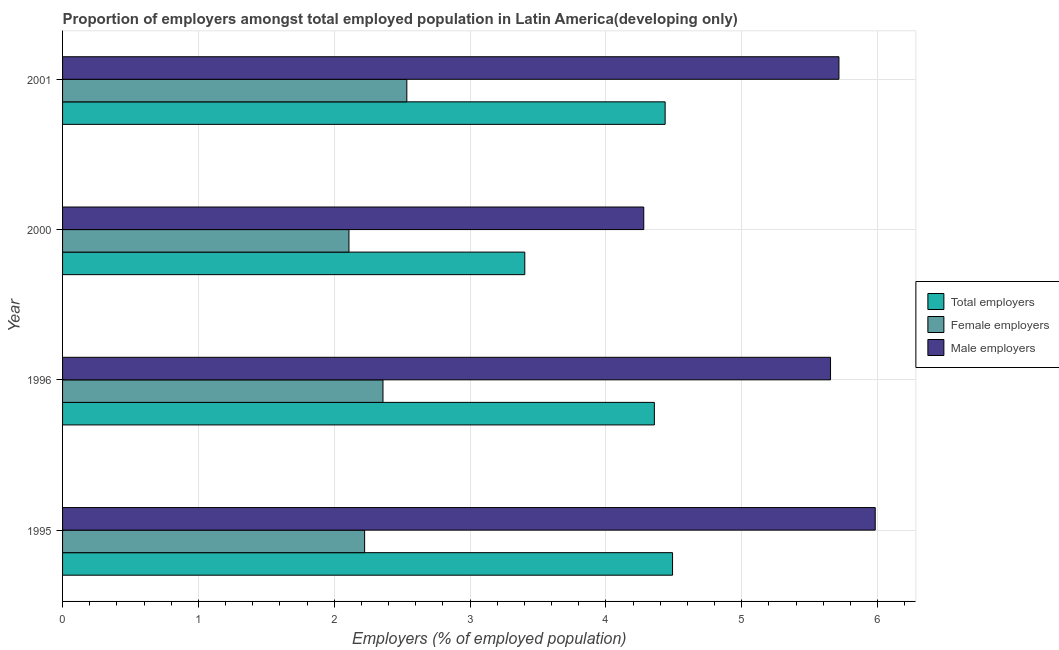Are the number of bars per tick equal to the number of legend labels?
Provide a short and direct response. Yes. Are the number of bars on each tick of the Y-axis equal?
Your answer should be compact. Yes. What is the label of the 2nd group of bars from the top?
Give a very brief answer. 2000. What is the percentage of female employers in 2001?
Keep it short and to the point. 2.53. Across all years, what is the maximum percentage of male employers?
Make the answer very short. 5.98. Across all years, what is the minimum percentage of total employers?
Offer a very short reply. 3.4. In which year was the percentage of total employers maximum?
Provide a short and direct response. 1995. In which year was the percentage of male employers minimum?
Your answer should be compact. 2000. What is the total percentage of total employers in the graph?
Your answer should be compact. 16.69. What is the difference between the percentage of male employers in 1995 and that in 2000?
Your answer should be compact. 1.7. What is the difference between the percentage of female employers in 2000 and the percentage of total employers in 1996?
Provide a short and direct response. -2.25. What is the average percentage of female employers per year?
Give a very brief answer. 2.31. In the year 2001, what is the difference between the percentage of total employers and percentage of male employers?
Provide a succinct answer. -1.28. What is the ratio of the percentage of total employers in 2000 to that in 2001?
Provide a short and direct response. 0.77. Is the percentage of male employers in 1995 less than that in 2000?
Offer a very short reply. No. What is the difference between the highest and the second highest percentage of female employers?
Offer a terse response. 0.18. What is the difference between the highest and the lowest percentage of total employers?
Your answer should be compact. 1.09. In how many years, is the percentage of total employers greater than the average percentage of total employers taken over all years?
Offer a very short reply. 3. Is the sum of the percentage of total employers in 1996 and 2001 greater than the maximum percentage of male employers across all years?
Provide a succinct answer. Yes. What does the 3rd bar from the top in 2000 represents?
Your response must be concise. Total employers. What does the 3rd bar from the bottom in 2001 represents?
Offer a very short reply. Male employers. How many years are there in the graph?
Provide a succinct answer. 4. Are the values on the major ticks of X-axis written in scientific E-notation?
Provide a succinct answer. No. Where does the legend appear in the graph?
Make the answer very short. Center right. How many legend labels are there?
Offer a terse response. 3. What is the title of the graph?
Make the answer very short. Proportion of employers amongst total employed population in Latin America(developing only). Does "Neonatal" appear as one of the legend labels in the graph?
Make the answer very short. No. What is the label or title of the X-axis?
Make the answer very short. Employers (% of employed population). What is the label or title of the Y-axis?
Keep it short and to the point. Year. What is the Employers (% of employed population) in Total employers in 1995?
Make the answer very short. 4.49. What is the Employers (% of employed population) of Female employers in 1995?
Keep it short and to the point. 2.22. What is the Employers (% of employed population) of Male employers in 1995?
Your answer should be very brief. 5.98. What is the Employers (% of employed population) in Total employers in 1996?
Ensure brevity in your answer.  4.36. What is the Employers (% of employed population) in Female employers in 1996?
Provide a succinct answer. 2.36. What is the Employers (% of employed population) of Male employers in 1996?
Give a very brief answer. 5.65. What is the Employers (% of employed population) in Total employers in 2000?
Ensure brevity in your answer.  3.4. What is the Employers (% of employed population) of Female employers in 2000?
Provide a short and direct response. 2.11. What is the Employers (% of employed population) in Male employers in 2000?
Keep it short and to the point. 4.28. What is the Employers (% of employed population) in Total employers in 2001?
Provide a short and direct response. 4.44. What is the Employers (% of employed population) in Female employers in 2001?
Keep it short and to the point. 2.53. What is the Employers (% of employed population) of Male employers in 2001?
Keep it short and to the point. 5.72. Across all years, what is the maximum Employers (% of employed population) in Total employers?
Make the answer very short. 4.49. Across all years, what is the maximum Employers (% of employed population) of Female employers?
Provide a succinct answer. 2.53. Across all years, what is the maximum Employers (% of employed population) in Male employers?
Your answer should be compact. 5.98. Across all years, what is the minimum Employers (% of employed population) of Total employers?
Provide a succinct answer. 3.4. Across all years, what is the minimum Employers (% of employed population) of Female employers?
Provide a short and direct response. 2.11. Across all years, what is the minimum Employers (% of employed population) of Male employers?
Provide a succinct answer. 4.28. What is the total Employers (% of employed population) of Total employers in the graph?
Your answer should be compact. 16.69. What is the total Employers (% of employed population) of Female employers in the graph?
Offer a very short reply. 9.22. What is the total Employers (% of employed population) of Male employers in the graph?
Your answer should be compact. 21.63. What is the difference between the Employers (% of employed population) of Total employers in 1995 and that in 1996?
Provide a succinct answer. 0.13. What is the difference between the Employers (% of employed population) of Female employers in 1995 and that in 1996?
Your response must be concise. -0.14. What is the difference between the Employers (% of employed population) of Male employers in 1995 and that in 1996?
Your response must be concise. 0.33. What is the difference between the Employers (% of employed population) in Total employers in 1995 and that in 2000?
Keep it short and to the point. 1.09. What is the difference between the Employers (% of employed population) in Female employers in 1995 and that in 2000?
Provide a short and direct response. 0.12. What is the difference between the Employers (% of employed population) in Male employers in 1995 and that in 2000?
Provide a short and direct response. 1.7. What is the difference between the Employers (% of employed population) of Total employers in 1995 and that in 2001?
Your response must be concise. 0.05. What is the difference between the Employers (% of employed population) in Female employers in 1995 and that in 2001?
Provide a succinct answer. -0.31. What is the difference between the Employers (% of employed population) of Male employers in 1995 and that in 2001?
Your answer should be compact. 0.27. What is the difference between the Employers (% of employed population) in Total employers in 1996 and that in 2000?
Give a very brief answer. 0.95. What is the difference between the Employers (% of employed population) of Female employers in 1996 and that in 2000?
Your answer should be very brief. 0.25. What is the difference between the Employers (% of employed population) in Male employers in 1996 and that in 2000?
Your response must be concise. 1.37. What is the difference between the Employers (% of employed population) of Total employers in 1996 and that in 2001?
Offer a terse response. -0.08. What is the difference between the Employers (% of employed population) of Female employers in 1996 and that in 2001?
Offer a terse response. -0.18. What is the difference between the Employers (% of employed population) in Male employers in 1996 and that in 2001?
Offer a very short reply. -0.06. What is the difference between the Employers (% of employed population) in Total employers in 2000 and that in 2001?
Keep it short and to the point. -1.03. What is the difference between the Employers (% of employed population) of Female employers in 2000 and that in 2001?
Offer a terse response. -0.43. What is the difference between the Employers (% of employed population) in Male employers in 2000 and that in 2001?
Offer a terse response. -1.44. What is the difference between the Employers (% of employed population) of Total employers in 1995 and the Employers (% of employed population) of Female employers in 1996?
Make the answer very short. 2.13. What is the difference between the Employers (% of employed population) in Total employers in 1995 and the Employers (% of employed population) in Male employers in 1996?
Provide a succinct answer. -1.16. What is the difference between the Employers (% of employed population) of Female employers in 1995 and the Employers (% of employed population) of Male employers in 1996?
Provide a short and direct response. -3.43. What is the difference between the Employers (% of employed population) in Total employers in 1995 and the Employers (% of employed population) in Female employers in 2000?
Your response must be concise. 2.38. What is the difference between the Employers (% of employed population) of Total employers in 1995 and the Employers (% of employed population) of Male employers in 2000?
Offer a terse response. 0.21. What is the difference between the Employers (% of employed population) of Female employers in 1995 and the Employers (% of employed population) of Male employers in 2000?
Make the answer very short. -2.05. What is the difference between the Employers (% of employed population) in Total employers in 1995 and the Employers (% of employed population) in Female employers in 2001?
Keep it short and to the point. 1.96. What is the difference between the Employers (% of employed population) of Total employers in 1995 and the Employers (% of employed population) of Male employers in 2001?
Give a very brief answer. -1.22. What is the difference between the Employers (% of employed population) of Female employers in 1995 and the Employers (% of employed population) of Male employers in 2001?
Provide a succinct answer. -3.49. What is the difference between the Employers (% of employed population) in Total employers in 1996 and the Employers (% of employed population) in Female employers in 2000?
Ensure brevity in your answer.  2.25. What is the difference between the Employers (% of employed population) of Total employers in 1996 and the Employers (% of employed population) of Male employers in 2000?
Ensure brevity in your answer.  0.08. What is the difference between the Employers (% of employed population) in Female employers in 1996 and the Employers (% of employed population) in Male employers in 2000?
Ensure brevity in your answer.  -1.92. What is the difference between the Employers (% of employed population) of Total employers in 1996 and the Employers (% of employed population) of Female employers in 2001?
Provide a short and direct response. 1.82. What is the difference between the Employers (% of employed population) of Total employers in 1996 and the Employers (% of employed population) of Male employers in 2001?
Your answer should be very brief. -1.36. What is the difference between the Employers (% of employed population) in Female employers in 1996 and the Employers (% of employed population) in Male employers in 2001?
Ensure brevity in your answer.  -3.36. What is the difference between the Employers (% of employed population) of Total employers in 2000 and the Employers (% of employed population) of Female employers in 2001?
Your answer should be compact. 0.87. What is the difference between the Employers (% of employed population) in Total employers in 2000 and the Employers (% of employed population) in Male employers in 2001?
Your answer should be very brief. -2.31. What is the difference between the Employers (% of employed population) in Female employers in 2000 and the Employers (% of employed population) in Male employers in 2001?
Provide a succinct answer. -3.61. What is the average Employers (% of employed population) in Total employers per year?
Keep it short and to the point. 4.17. What is the average Employers (% of employed population) of Female employers per year?
Give a very brief answer. 2.31. What is the average Employers (% of employed population) in Male employers per year?
Give a very brief answer. 5.41. In the year 1995, what is the difference between the Employers (% of employed population) of Total employers and Employers (% of employed population) of Female employers?
Your response must be concise. 2.27. In the year 1995, what is the difference between the Employers (% of employed population) in Total employers and Employers (% of employed population) in Male employers?
Provide a succinct answer. -1.49. In the year 1995, what is the difference between the Employers (% of employed population) of Female employers and Employers (% of employed population) of Male employers?
Offer a very short reply. -3.76. In the year 1996, what is the difference between the Employers (% of employed population) of Total employers and Employers (% of employed population) of Female employers?
Provide a succinct answer. 2. In the year 1996, what is the difference between the Employers (% of employed population) of Total employers and Employers (% of employed population) of Male employers?
Ensure brevity in your answer.  -1.3. In the year 1996, what is the difference between the Employers (% of employed population) of Female employers and Employers (% of employed population) of Male employers?
Your response must be concise. -3.29. In the year 2000, what is the difference between the Employers (% of employed population) of Total employers and Employers (% of employed population) of Female employers?
Your answer should be very brief. 1.29. In the year 2000, what is the difference between the Employers (% of employed population) of Total employers and Employers (% of employed population) of Male employers?
Provide a short and direct response. -0.88. In the year 2000, what is the difference between the Employers (% of employed population) in Female employers and Employers (% of employed population) in Male employers?
Offer a very short reply. -2.17. In the year 2001, what is the difference between the Employers (% of employed population) of Total employers and Employers (% of employed population) of Female employers?
Provide a succinct answer. 1.9. In the year 2001, what is the difference between the Employers (% of employed population) of Total employers and Employers (% of employed population) of Male employers?
Keep it short and to the point. -1.28. In the year 2001, what is the difference between the Employers (% of employed population) of Female employers and Employers (% of employed population) of Male employers?
Offer a very short reply. -3.18. What is the ratio of the Employers (% of employed population) in Total employers in 1995 to that in 1996?
Make the answer very short. 1.03. What is the ratio of the Employers (% of employed population) of Female employers in 1995 to that in 1996?
Offer a terse response. 0.94. What is the ratio of the Employers (% of employed population) of Male employers in 1995 to that in 1996?
Your answer should be compact. 1.06. What is the ratio of the Employers (% of employed population) of Total employers in 1995 to that in 2000?
Your answer should be compact. 1.32. What is the ratio of the Employers (% of employed population) of Female employers in 1995 to that in 2000?
Offer a terse response. 1.05. What is the ratio of the Employers (% of employed population) of Male employers in 1995 to that in 2000?
Provide a short and direct response. 1.4. What is the ratio of the Employers (% of employed population) of Total employers in 1995 to that in 2001?
Provide a short and direct response. 1.01. What is the ratio of the Employers (% of employed population) of Female employers in 1995 to that in 2001?
Offer a very short reply. 0.88. What is the ratio of the Employers (% of employed population) of Male employers in 1995 to that in 2001?
Your answer should be compact. 1.05. What is the ratio of the Employers (% of employed population) of Total employers in 1996 to that in 2000?
Your answer should be very brief. 1.28. What is the ratio of the Employers (% of employed population) of Female employers in 1996 to that in 2000?
Give a very brief answer. 1.12. What is the ratio of the Employers (% of employed population) in Male employers in 1996 to that in 2000?
Offer a very short reply. 1.32. What is the ratio of the Employers (% of employed population) of Total employers in 1996 to that in 2001?
Make the answer very short. 0.98. What is the ratio of the Employers (% of employed population) in Female employers in 1996 to that in 2001?
Provide a short and direct response. 0.93. What is the ratio of the Employers (% of employed population) of Male employers in 1996 to that in 2001?
Provide a succinct answer. 0.99. What is the ratio of the Employers (% of employed population) of Total employers in 2000 to that in 2001?
Keep it short and to the point. 0.77. What is the ratio of the Employers (% of employed population) in Female employers in 2000 to that in 2001?
Your response must be concise. 0.83. What is the ratio of the Employers (% of employed population) of Male employers in 2000 to that in 2001?
Keep it short and to the point. 0.75. What is the difference between the highest and the second highest Employers (% of employed population) in Total employers?
Your answer should be very brief. 0.05. What is the difference between the highest and the second highest Employers (% of employed population) of Female employers?
Make the answer very short. 0.18. What is the difference between the highest and the second highest Employers (% of employed population) in Male employers?
Your answer should be compact. 0.27. What is the difference between the highest and the lowest Employers (% of employed population) of Total employers?
Your answer should be compact. 1.09. What is the difference between the highest and the lowest Employers (% of employed population) of Female employers?
Your answer should be compact. 0.43. What is the difference between the highest and the lowest Employers (% of employed population) in Male employers?
Keep it short and to the point. 1.7. 